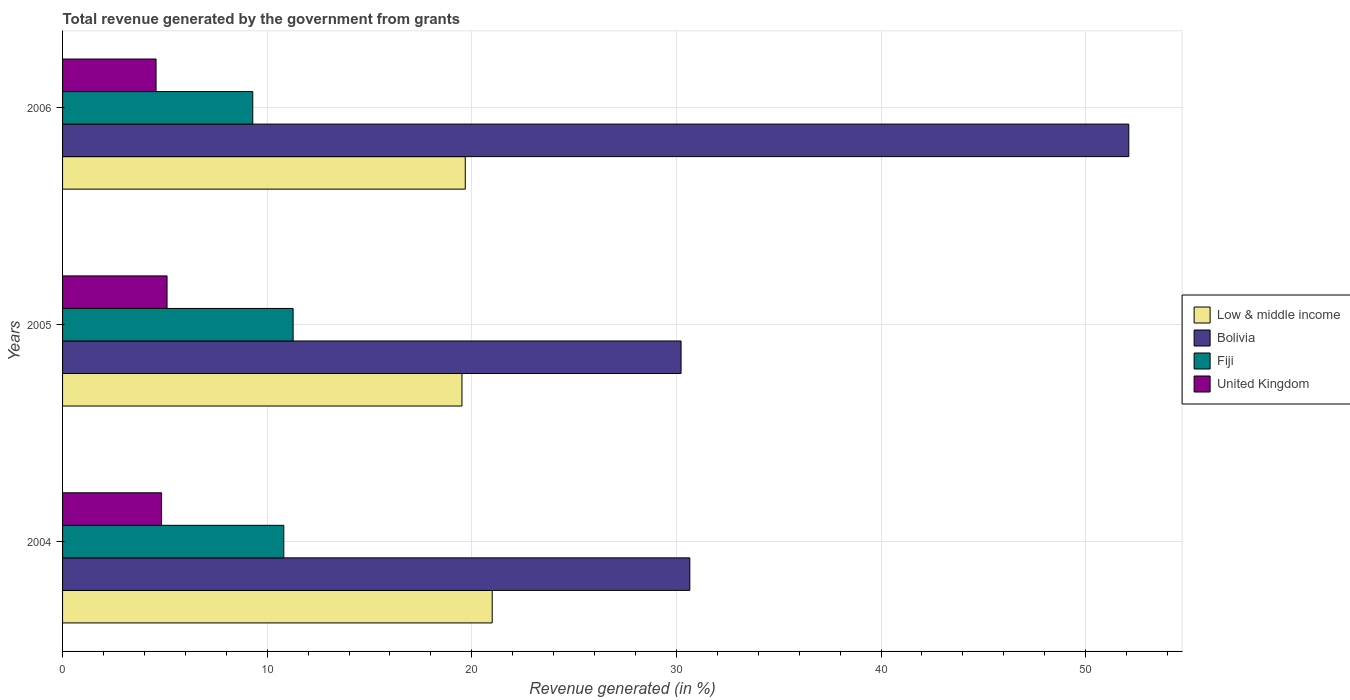How many different coloured bars are there?
Make the answer very short. 4. How many groups of bars are there?
Keep it short and to the point. 3. Are the number of bars per tick equal to the number of legend labels?
Offer a terse response. Yes. How many bars are there on the 3rd tick from the top?
Make the answer very short. 4. What is the label of the 1st group of bars from the top?
Provide a short and direct response. 2006. What is the total revenue generated in Low & middle income in 2004?
Make the answer very short. 21. Across all years, what is the maximum total revenue generated in Fiji?
Give a very brief answer. 11.27. Across all years, what is the minimum total revenue generated in Low & middle income?
Your answer should be very brief. 19.52. In which year was the total revenue generated in Fiji maximum?
Provide a short and direct response. 2005. In which year was the total revenue generated in United Kingdom minimum?
Your response must be concise. 2006. What is the total total revenue generated in Bolivia in the graph?
Your response must be concise. 112.99. What is the difference between the total revenue generated in Fiji in 2004 and that in 2006?
Make the answer very short. 1.52. What is the difference between the total revenue generated in United Kingdom in 2004 and the total revenue generated in Fiji in 2005?
Your answer should be compact. -6.43. What is the average total revenue generated in Fiji per year?
Keep it short and to the point. 10.46. In the year 2005, what is the difference between the total revenue generated in Fiji and total revenue generated in United Kingdom?
Your answer should be very brief. 6.16. In how many years, is the total revenue generated in Fiji greater than 12 %?
Provide a succinct answer. 0. What is the ratio of the total revenue generated in Bolivia in 2005 to that in 2006?
Offer a terse response. 0.58. What is the difference between the highest and the second highest total revenue generated in Low & middle income?
Offer a terse response. 1.32. What is the difference between the highest and the lowest total revenue generated in United Kingdom?
Your answer should be very brief. 0.54. Is the sum of the total revenue generated in United Kingdom in 2005 and 2006 greater than the maximum total revenue generated in Bolivia across all years?
Make the answer very short. No. Is it the case that in every year, the sum of the total revenue generated in Low & middle income and total revenue generated in United Kingdom is greater than the sum of total revenue generated in Bolivia and total revenue generated in Fiji?
Your answer should be very brief. Yes. What does the 3rd bar from the bottom in 2005 represents?
Offer a terse response. Fiji. Are all the bars in the graph horizontal?
Your response must be concise. Yes. How many years are there in the graph?
Your answer should be very brief. 3. What is the difference between two consecutive major ticks on the X-axis?
Ensure brevity in your answer.  10. Are the values on the major ticks of X-axis written in scientific E-notation?
Your answer should be very brief. No. Does the graph contain any zero values?
Provide a short and direct response. No. Where does the legend appear in the graph?
Keep it short and to the point. Center right. How many legend labels are there?
Make the answer very short. 4. How are the legend labels stacked?
Provide a succinct answer. Vertical. What is the title of the graph?
Offer a very short reply. Total revenue generated by the government from grants. Does "Mauritania" appear as one of the legend labels in the graph?
Give a very brief answer. No. What is the label or title of the X-axis?
Your answer should be compact. Revenue generated (in %). What is the Revenue generated (in %) of Low & middle income in 2004?
Offer a very short reply. 21. What is the Revenue generated (in %) in Bolivia in 2004?
Your answer should be compact. 30.66. What is the Revenue generated (in %) in Fiji in 2004?
Ensure brevity in your answer.  10.81. What is the Revenue generated (in %) in United Kingdom in 2004?
Your answer should be very brief. 4.84. What is the Revenue generated (in %) of Low & middle income in 2005?
Ensure brevity in your answer.  19.52. What is the Revenue generated (in %) in Bolivia in 2005?
Your answer should be compact. 30.23. What is the Revenue generated (in %) in Fiji in 2005?
Give a very brief answer. 11.27. What is the Revenue generated (in %) in United Kingdom in 2005?
Keep it short and to the point. 5.11. What is the Revenue generated (in %) of Low & middle income in 2006?
Your response must be concise. 19.68. What is the Revenue generated (in %) in Bolivia in 2006?
Keep it short and to the point. 52.11. What is the Revenue generated (in %) in Fiji in 2006?
Your answer should be very brief. 9.3. What is the Revenue generated (in %) in United Kingdom in 2006?
Give a very brief answer. 4.57. Across all years, what is the maximum Revenue generated (in %) of Low & middle income?
Offer a very short reply. 21. Across all years, what is the maximum Revenue generated (in %) in Bolivia?
Your answer should be very brief. 52.11. Across all years, what is the maximum Revenue generated (in %) in Fiji?
Make the answer very short. 11.27. Across all years, what is the maximum Revenue generated (in %) of United Kingdom?
Make the answer very short. 5.11. Across all years, what is the minimum Revenue generated (in %) in Low & middle income?
Keep it short and to the point. 19.52. Across all years, what is the minimum Revenue generated (in %) of Bolivia?
Ensure brevity in your answer.  30.23. Across all years, what is the minimum Revenue generated (in %) in Fiji?
Offer a very short reply. 9.3. Across all years, what is the minimum Revenue generated (in %) of United Kingdom?
Make the answer very short. 4.57. What is the total Revenue generated (in %) of Low & middle income in the graph?
Provide a short and direct response. 60.2. What is the total Revenue generated (in %) of Bolivia in the graph?
Keep it short and to the point. 112.99. What is the total Revenue generated (in %) of Fiji in the graph?
Give a very brief answer. 31.37. What is the total Revenue generated (in %) of United Kingdom in the graph?
Provide a short and direct response. 14.51. What is the difference between the Revenue generated (in %) of Low & middle income in 2004 and that in 2005?
Offer a very short reply. 1.48. What is the difference between the Revenue generated (in %) of Bolivia in 2004 and that in 2005?
Offer a very short reply. 0.43. What is the difference between the Revenue generated (in %) of Fiji in 2004 and that in 2005?
Give a very brief answer. -0.46. What is the difference between the Revenue generated (in %) in United Kingdom in 2004 and that in 2005?
Give a very brief answer. -0.27. What is the difference between the Revenue generated (in %) in Low & middle income in 2004 and that in 2006?
Your answer should be compact. 1.32. What is the difference between the Revenue generated (in %) of Bolivia in 2004 and that in 2006?
Your answer should be very brief. -21.45. What is the difference between the Revenue generated (in %) of Fiji in 2004 and that in 2006?
Offer a very short reply. 1.52. What is the difference between the Revenue generated (in %) in United Kingdom in 2004 and that in 2006?
Give a very brief answer. 0.27. What is the difference between the Revenue generated (in %) in Low & middle income in 2005 and that in 2006?
Give a very brief answer. -0.16. What is the difference between the Revenue generated (in %) of Bolivia in 2005 and that in 2006?
Give a very brief answer. -21.88. What is the difference between the Revenue generated (in %) in Fiji in 2005 and that in 2006?
Give a very brief answer. 1.97. What is the difference between the Revenue generated (in %) in United Kingdom in 2005 and that in 2006?
Provide a short and direct response. 0.54. What is the difference between the Revenue generated (in %) of Low & middle income in 2004 and the Revenue generated (in %) of Bolivia in 2005?
Give a very brief answer. -9.23. What is the difference between the Revenue generated (in %) in Low & middle income in 2004 and the Revenue generated (in %) in Fiji in 2005?
Keep it short and to the point. 9.73. What is the difference between the Revenue generated (in %) of Low & middle income in 2004 and the Revenue generated (in %) of United Kingdom in 2005?
Offer a very short reply. 15.89. What is the difference between the Revenue generated (in %) of Bolivia in 2004 and the Revenue generated (in %) of Fiji in 2005?
Ensure brevity in your answer.  19.39. What is the difference between the Revenue generated (in %) in Bolivia in 2004 and the Revenue generated (in %) in United Kingdom in 2005?
Keep it short and to the point. 25.55. What is the difference between the Revenue generated (in %) in Fiji in 2004 and the Revenue generated (in %) in United Kingdom in 2005?
Ensure brevity in your answer.  5.71. What is the difference between the Revenue generated (in %) in Low & middle income in 2004 and the Revenue generated (in %) in Bolivia in 2006?
Your response must be concise. -31.11. What is the difference between the Revenue generated (in %) of Low & middle income in 2004 and the Revenue generated (in %) of Fiji in 2006?
Make the answer very short. 11.7. What is the difference between the Revenue generated (in %) in Low & middle income in 2004 and the Revenue generated (in %) in United Kingdom in 2006?
Your answer should be compact. 16.43. What is the difference between the Revenue generated (in %) of Bolivia in 2004 and the Revenue generated (in %) of Fiji in 2006?
Your answer should be compact. 21.36. What is the difference between the Revenue generated (in %) in Bolivia in 2004 and the Revenue generated (in %) in United Kingdom in 2006?
Offer a terse response. 26.09. What is the difference between the Revenue generated (in %) of Fiji in 2004 and the Revenue generated (in %) of United Kingdom in 2006?
Provide a short and direct response. 6.24. What is the difference between the Revenue generated (in %) in Low & middle income in 2005 and the Revenue generated (in %) in Bolivia in 2006?
Give a very brief answer. -32.59. What is the difference between the Revenue generated (in %) in Low & middle income in 2005 and the Revenue generated (in %) in Fiji in 2006?
Your response must be concise. 10.22. What is the difference between the Revenue generated (in %) in Low & middle income in 2005 and the Revenue generated (in %) in United Kingdom in 2006?
Provide a short and direct response. 14.95. What is the difference between the Revenue generated (in %) in Bolivia in 2005 and the Revenue generated (in %) in Fiji in 2006?
Offer a very short reply. 20.93. What is the difference between the Revenue generated (in %) of Bolivia in 2005 and the Revenue generated (in %) of United Kingdom in 2006?
Offer a terse response. 25.66. What is the difference between the Revenue generated (in %) in Fiji in 2005 and the Revenue generated (in %) in United Kingdom in 2006?
Keep it short and to the point. 6.7. What is the average Revenue generated (in %) in Low & middle income per year?
Your answer should be very brief. 20.07. What is the average Revenue generated (in %) of Bolivia per year?
Give a very brief answer. 37.66. What is the average Revenue generated (in %) in Fiji per year?
Keep it short and to the point. 10.46. What is the average Revenue generated (in %) in United Kingdom per year?
Make the answer very short. 4.84. In the year 2004, what is the difference between the Revenue generated (in %) in Low & middle income and Revenue generated (in %) in Bolivia?
Keep it short and to the point. -9.66. In the year 2004, what is the difference between the Revenue generated (in %) in Low & middle income and Revenue generated (in %) in Fiji?
Your response must be concise. 10.19. In the year 2004, what is the difference between the Revenue generated (in %) of Low & middle income and Revenue generated (in %) of United Kingdom?
Provide a short and direct response. 16.16. In the year 2004, what is the difference between the Revenue generated (in %) in Bolivia and Revenue generated (in %) in Fiji?
Keep it short and to the point. 19.84. In the year 2004, what is the difference between the Revenue generated (in %) in Bolivia and Revenue generated (in %) in United Kingdom?
Offer a terse response. 25.82. In the year 2004, what is the difference between the Revenue generated (in %) in Fiji and Revenue generated (in %) in United Kingdom?
Give a very brief answer. 5.97. In the year 2005, what is the difference between the Revenue generated (in %) of Low & middle income and Revenue generated (in %) of Bolivia?
Give a very brief answer. -10.71. In the year 2005, what is the difference between the Revenue generated (in %) of Low & middle income and Revenue generated (in %) of Fiji?
Your response must be concise. 8.25. In the year 2005, what is the difference between the Revenue generated (in %) in Low & middle income and Revenue generated (in %) in United Kingdom?
Your response must be concise. 14.41. In the year 2005, what is the difference between the Revenue generated (in %) in Bolivia and Revenue generated (in %) in Fiji?
Your answer should be very brief. 18.96. In the year 2005, what is the difference between the Revenue generated (in %) of Bolivia and Revenue generated (in %) of United Kingdom?
Offer a terse response. 25.12. In the year 2005, what is the difference between the Revenue generated (in %) of Fiji and Revenue generated (in %) of United Kingdom?
Ensure brevity in your answer.  6.16. In the year 2006, what is the difference between the Revenue generated (in %) in Low & middle income and Revenue generated (in %) in Bolivia?
Your response must be concise. -32.43. In the year 2006, what is the difference between the Revenue generated (in %) of Low & middle income and Revenue generated (in %) of Fiji?
Provide a short and direct response. 10.39. In the year 2006, what is the difference between the Revenue generated (in %) in Low & middle income and Revenue generated (in %) in United Kingdom?
Make the answer very short. 15.11. In the year 2006, what is the difference between the Revenue generated (in %) in Bolivia and Revenue generated (in %) in Fiji?
Provide a short and direct response. 42.81. In the year 2006, what is the difference between the Revenue generated (in %) of Bolivia and Revenue generated (in %) of United Kingdom?
Offer a very short reply. 47.54. In the year 2006, what is the difference between the Revenue generated (in %) in Fiji and Revenue generated (in %) in United Kingdom?
Provide a succinct answer. 4.73. What is the ratio of the Revenue generated (in %) in Low & middle income in 2004 to that in 2005?
Provide a succinct answer. 1.08. What is the ratio of the Revenue generated (in %) in Bolivia in 2004 to that in 2005?
Keep it short and to the point. 1.01. What is the ratio of the Revenue generated (in %) in Fiji in 2004 to that in 2005?
Make the answer very short. 0.96. What is the ratio of the Revenue generated (in %) in United Kingdom in 2004 to that in 2005?
Give a very brief answer. 0.95. What is the ratio of the Revenue generated (in %) of Low & middle income in 2004 to that in 2006?
Offer a terse response. 1.07. What is the ratio of the Revenue generated (in %) in Bolivia in 2004 to that in 2006?
Provide a succinct answer. 0.59. What is the ratio of the Revenue generated (in %) in Fiji in 2004 to that in 2006?
Your answer should be compact. 1.16. What is the ratio of the Revenue generated (in %) in United Kingdom in 2004 to that in 2006?
Ensure brevity in your answer.  1.06. What is the ratio of the Revenue generated (in %) of Low & middle income in 2005 to that in 2006?
Ensure brevity in your answer.  0.99. What is the ratio of the Revenue generated (in %) in Bolivia in 2005 to that in 2006?
Ensure brevity in your answer.  0.58. What is the ratio of the Revenue generated (in %) in Fiji in 2005 to that in 2006?
Offer a terse response. 1.21. What is the ratio of the Revenue generated (in %) in United Kingdom in 2005 to that in 2006?
Your answer should be compact. 1.12. What is the difference between the highest and the second highest Revenue generated (in %) in Low & middle income?
Provide a succinct answer. 1.32. What is the difference between the highest and the second highest Revenue generated (in %) in Bolivia?
Your response must be concise. 21.45. What is the difference between the highest and the second highest Revenue generated (in %) of Fiji?
Provide a short and direct response. 0.46. What is the difference between the highest and the second highest Revenue generated (in %) in United Kingdom?
Keep it short and to the point. 0.27. What is the difference between the highest and the lowest Revenue generated (in %) of Low & middle income?
Your response must be concise. 1.48. What is the difference between the highest and the lowest Revenue generated (in %) of Bolivia?
Your answer should be compact. 21.88. What is the difference between the highest and the lowest Revenue generated (in %) of Fiji?
Provide a short and direct response. 1.97. What is the difference between the highest and the lowest Revenue generated (in %) of United Kingdom?
Your answer should be very brief. 0.54. 